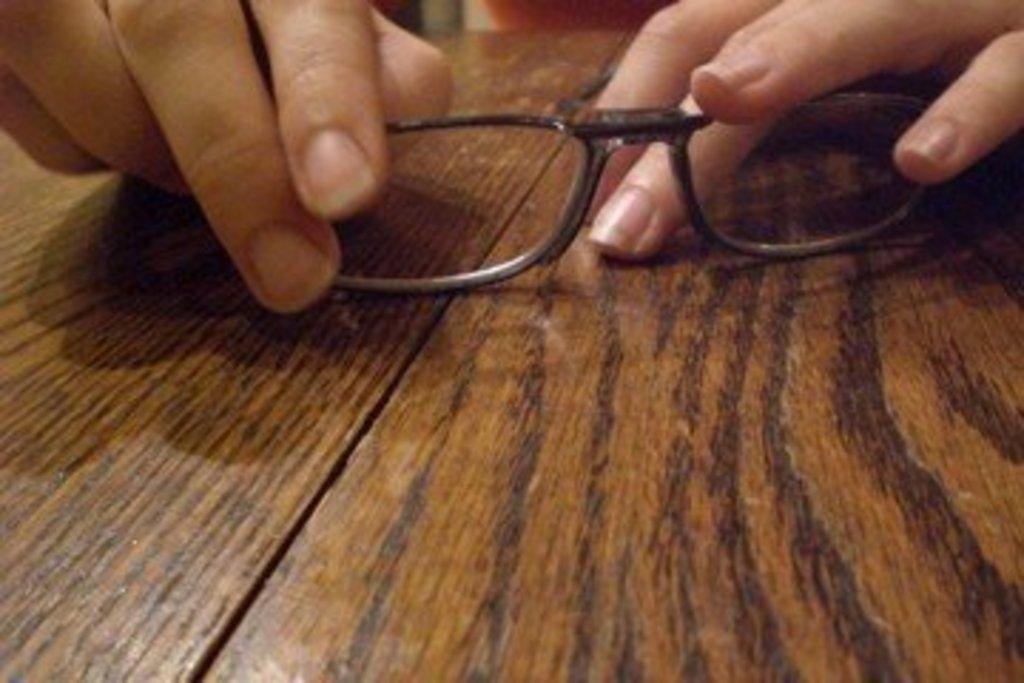What type of table is visible in the image? There is a wooden table in the image. What is the person in the image doing with their hand? A person's hand is holding an optical device in the image. What type of hobbies does the farmer have in the image? There is no farmer or mention of hobbies in the image; it only shows a wooden table and a person holding an optical device. 